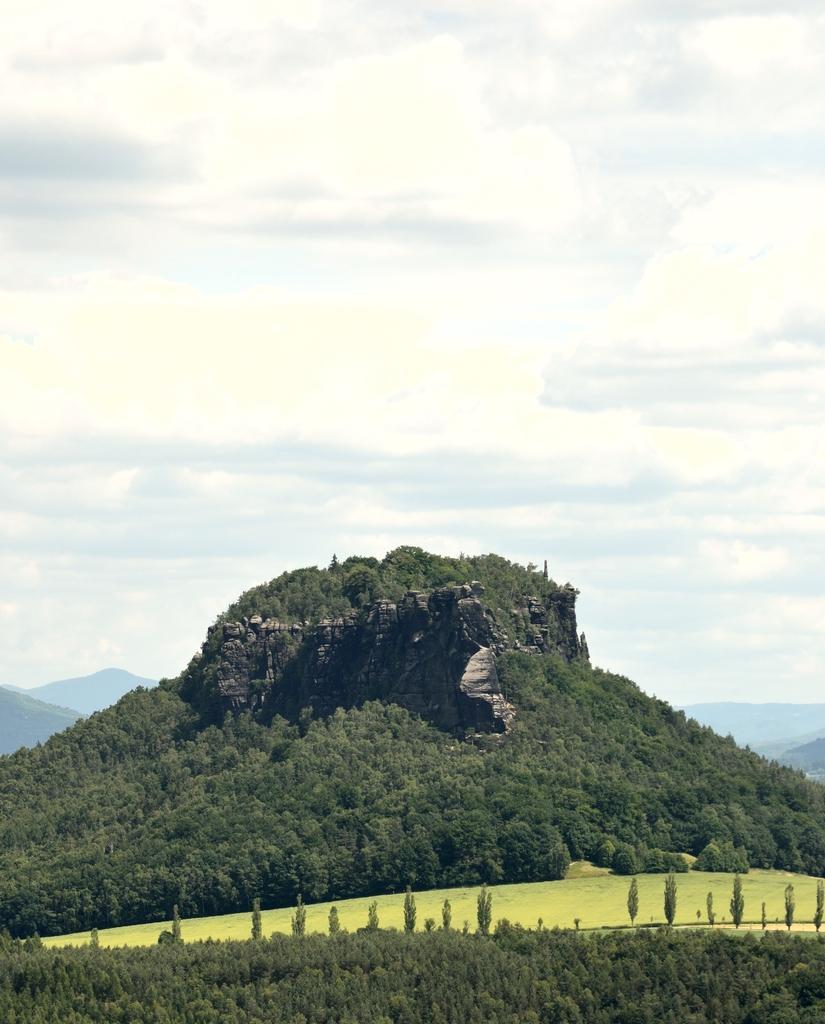Please provide a concise description of this image. At the bottom of the picture, we see the trees. In the middle, we see the grass. There are trees and the hills in the background. At the top, we see the sky and the clouds. 